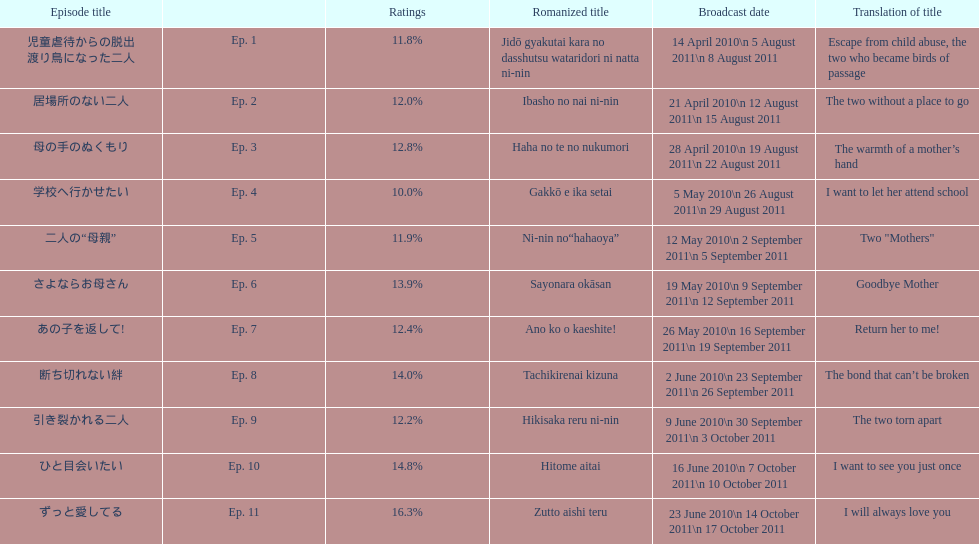How many episode total are there? 11. 